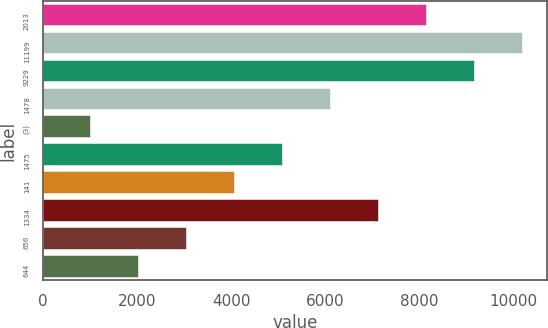<chart> <loc_0><loc_0><loc_500><loc_500><bar_chart><fcel>2013<fcel>11199<fcel>9229<fcel>1478<fcel>(3)<fcel>1475<fcel>141<fcel>1334<fcel>656<fcel>644<nl><fcel>8173.81<fcel>10217<fcel>9195.4<fcel>6130.65<fcel>1022.74<fcel>5109.07<fcel>4087.49<fcel>7152.23<fcel>3065.91<fcel>2044.33<nl></chart> 